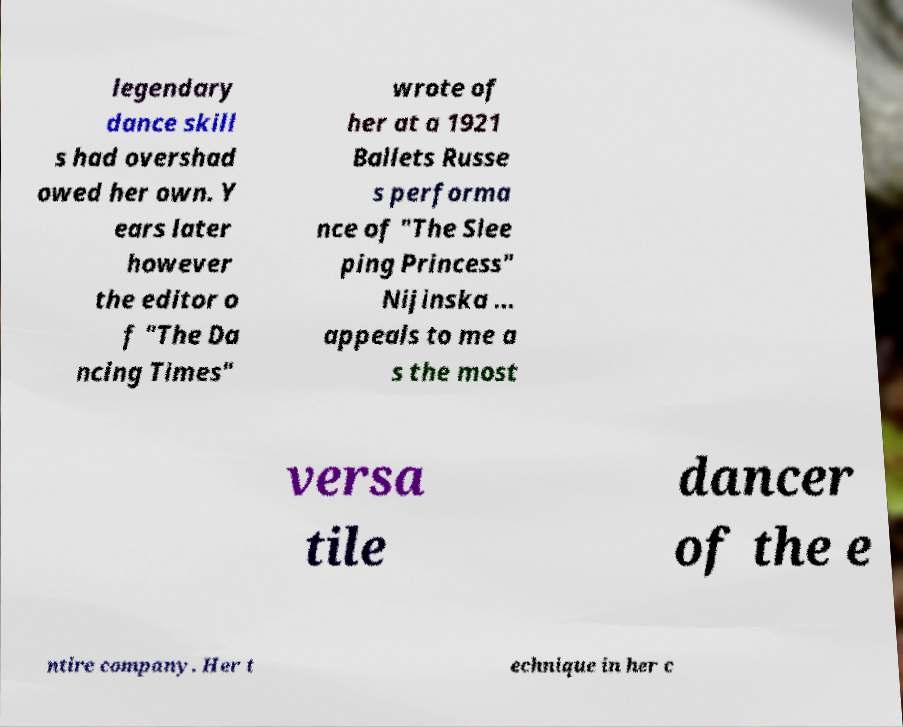Please read and relay the text visible in this image. What does it say? legendary dance skill s had overshad owed her own. Y ears later however the editor o f "The Da ncing Times" wrote of her at a 1921 Ballets Russe s performa nce of "The Slee ping Princess" Nijinska ... appeals to me a s the most versa tile dancer of the e ntire company. Her t echnique in her c 